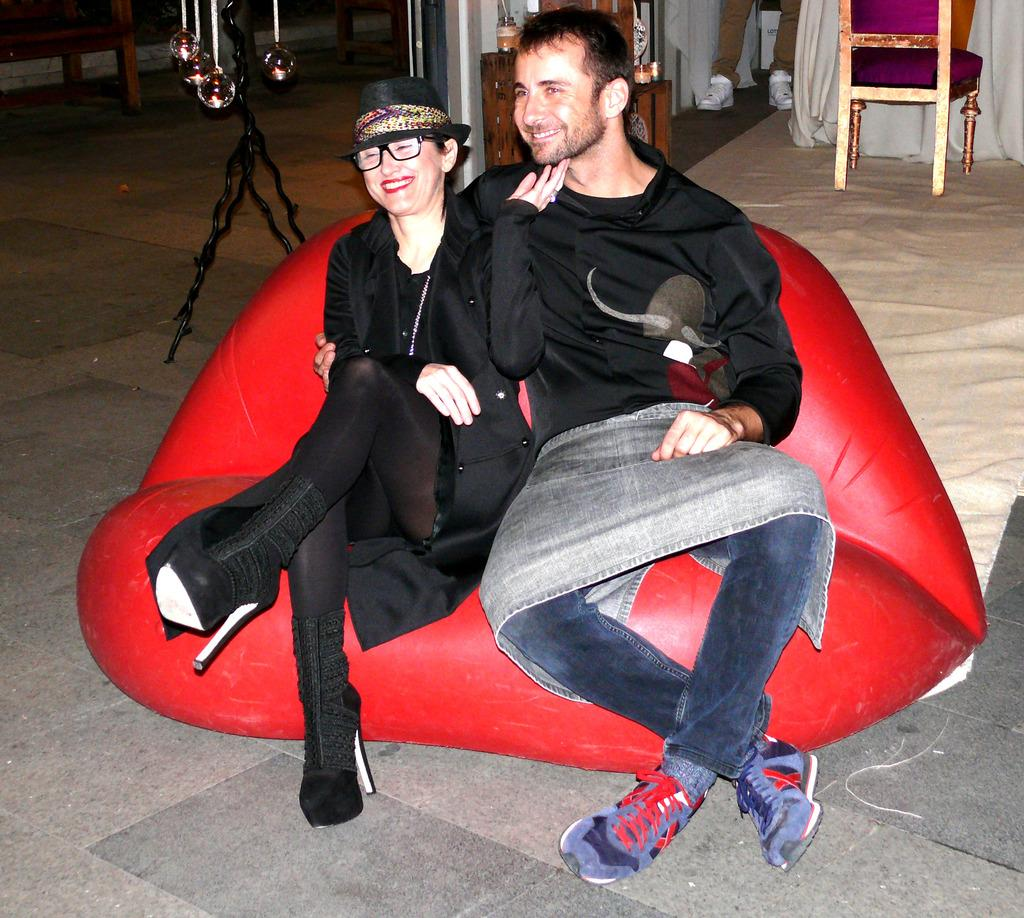Who is present in the image? There is a woman and a man in the image. What are the expressions on their faces? Both the woman and the man are smiling in the image. Where are they sitting? They are sitting on a couch in the image. What can be seen in the background? There is a chair and a person's leg visible in the background of the image. What type of twig is the woman holding in the image? There is no twig present in the image; the woman is not holding anything. How many toes can be seen on the man's foot in the image? There is no visible foot or toes of the man in the image. 